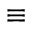Convert formula to latex. <formula><loc_0><loc_0><loc_500><loc_500>\equiv</formula> 